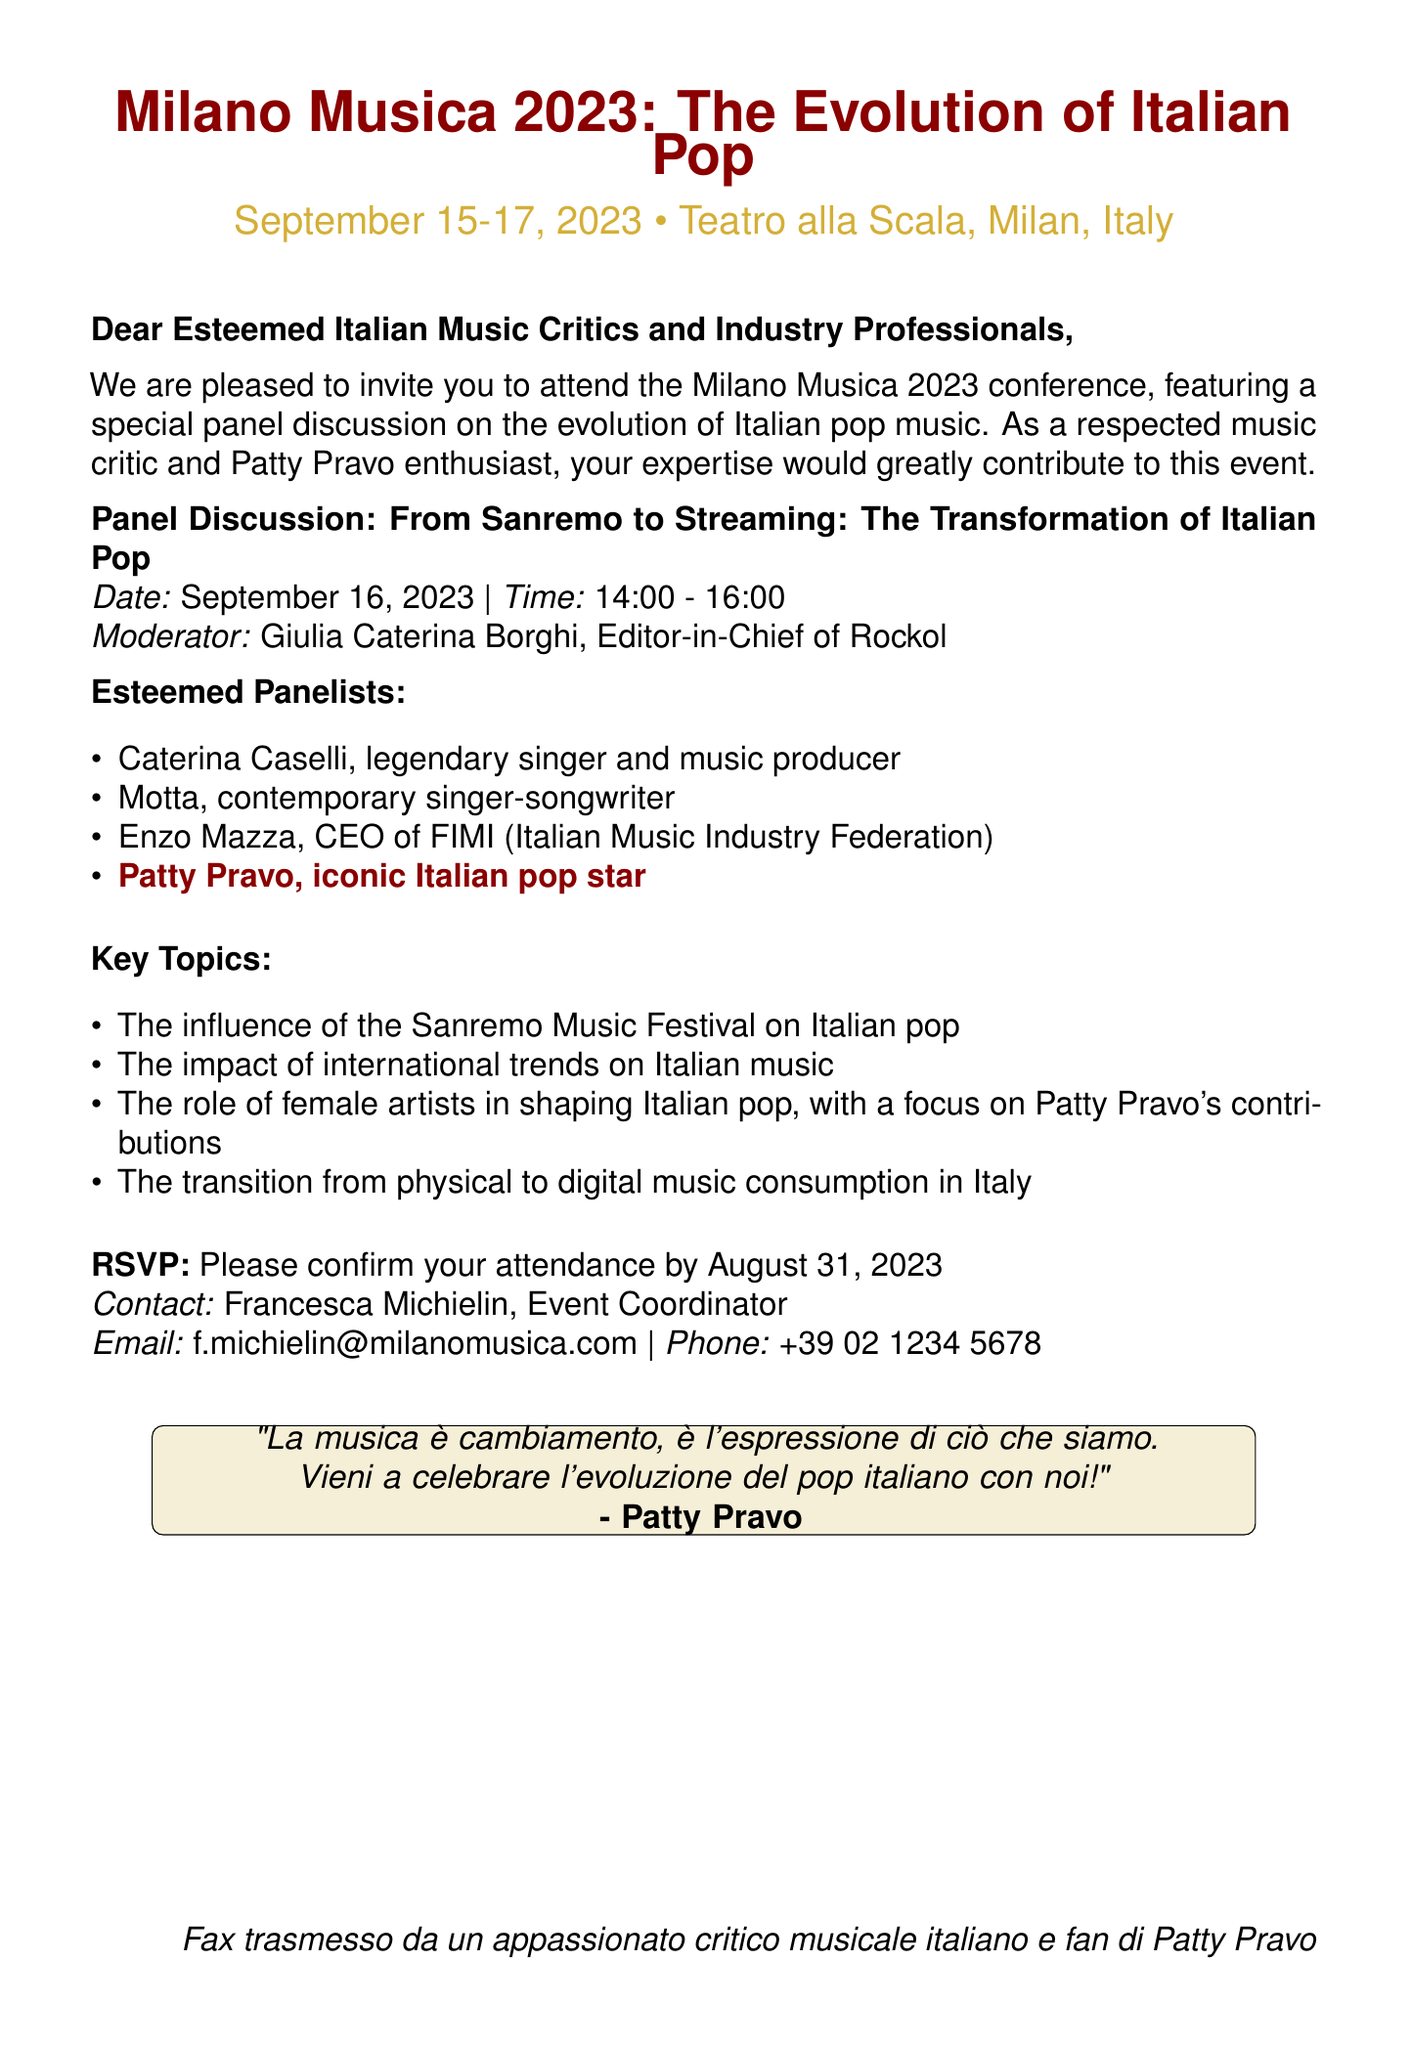What is the name of the conference? The document names the conference as "Milano Musica 2023."
Answer: Milano Musica 2023 What are the dates of the conference? The conference dates are specified in the document as September 15-17, 2023.
Answer: September 15-17, 2023 Who is the moderator of the panel discussion? The moderator's name is mentioned in the document as Giulia Caterina Borghi.
Answer: Giulia Caterina Borghi Which iconic artist is listed as a panelist? The document specifically highlights Patty Pravo as an iconic panelist.
Answer: Patty Pravo What is the theme of the panel discussion? The document describes the panel discussion theme as "From Sanremo to Streaming: The Transformation of Italian Pop."
Answer: From Sanremo to Streaming: The Transformation of Italian Pop What is the deadline for RSVP? The document states that the RSVP deadline is August 31, 2023.
Answer: August 31, 2023 What is the primary focus of the panel discussion regarding female artists? The document mentions a focus on Patty Pravo's contributions to the role of female artists in shaping Italian pop.
Answer: Patty Pravo's contributions Who is the contact person for the event? The document lists Francesca Michielin as the contact person for the event.
Answer: Francesca Michielin What is the location of the conference? The document specifies that the conference will be held at Teatro alla Scala, Milan, Italy.
Answer: Teatro alla Scala, Milan, Italy 